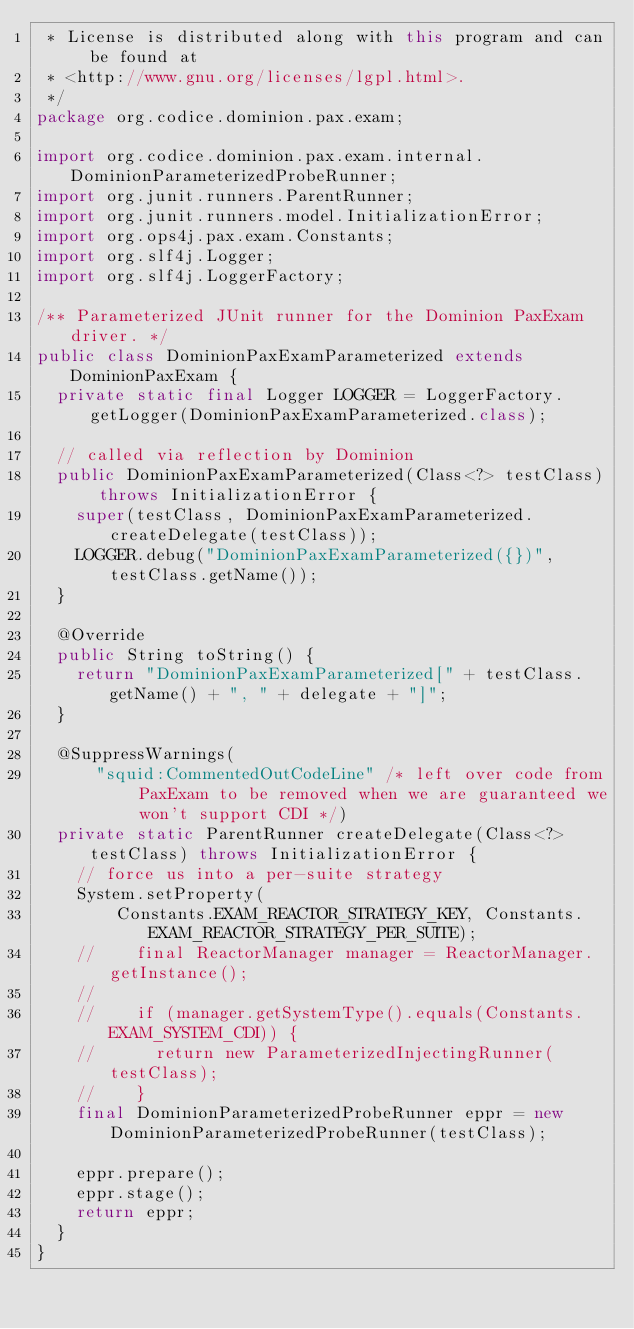<code> <loc_0><loc_0><loc_500><loc_500><_Java_> * License is distributed along with this program and can be found at
 * <http://www.gnu.org/licenses/lgpl.html>.
 */
package org.codice.dominion.pax.exam;

import org.codice.dominion.pax.exam.internal.DominionParameterizedProbeRunner;
import org.junit.runners.ParentRunner;
import org.junit.runners.model.InitializationError;
import org.ops4j.pax.exam.Constants;
import org.slf4j.Logger;
import org.slf4j.LoggerFactory;

/** Parameterized JUnit runner for the Dominion PaxExam driver. */
public class DominionPaxExamParameterized extends DominionPaxExam {
  private static final Logger LOGGER = LoggerFactory.getLogger(DominionPaxExamParameterized.class);

  // called via reflection by Dominion
  public DominionPaxExamParameterized(Class<?> testClass) throws InitializationError {
    super(testClass, DominionPaxExamParameterized.createDelegate(testClass));
    LOGGER.debug("DominionPaxExamParameterized({})", testClass.getName());
  }

  @Override
  public String toString() {
    return "DominionPaxExamParameterized[" + testClass.getName() + ", " + delegate + "]";
  }

  @SuppressWarnings(
      "squid:CommentedOutCodeLine" /* left over code from PaxExam to be removed when we are guaranteed we won't support CDI */)
  private static ParentRunner createDelegate(Class<?> testClass) throws InitializationError {
    // force us into a per-suite strategy
    System.setProperty(
        Constants.EXAM_REACTOR_STRATEGY_KEY, Constants.EXAM_REACTOR_STRATEGY_PER_SUITE);
    //    final ReactorManager manager = ReactorManager.getInstance();
    //
    //    if (manager.getSystemType().equals(Constants.EXAM_SYSTEM_CDI)) {
    //      return new ParameterizedInjectingRunner(testClass);
    //    }
    final DominionParameterizedProbeRunner eppr = new DominionParameterizedProbeRunner(testClass);

    eppr.prepare();
    eppr.stage();
    return eppr;
  }
}
</code> 